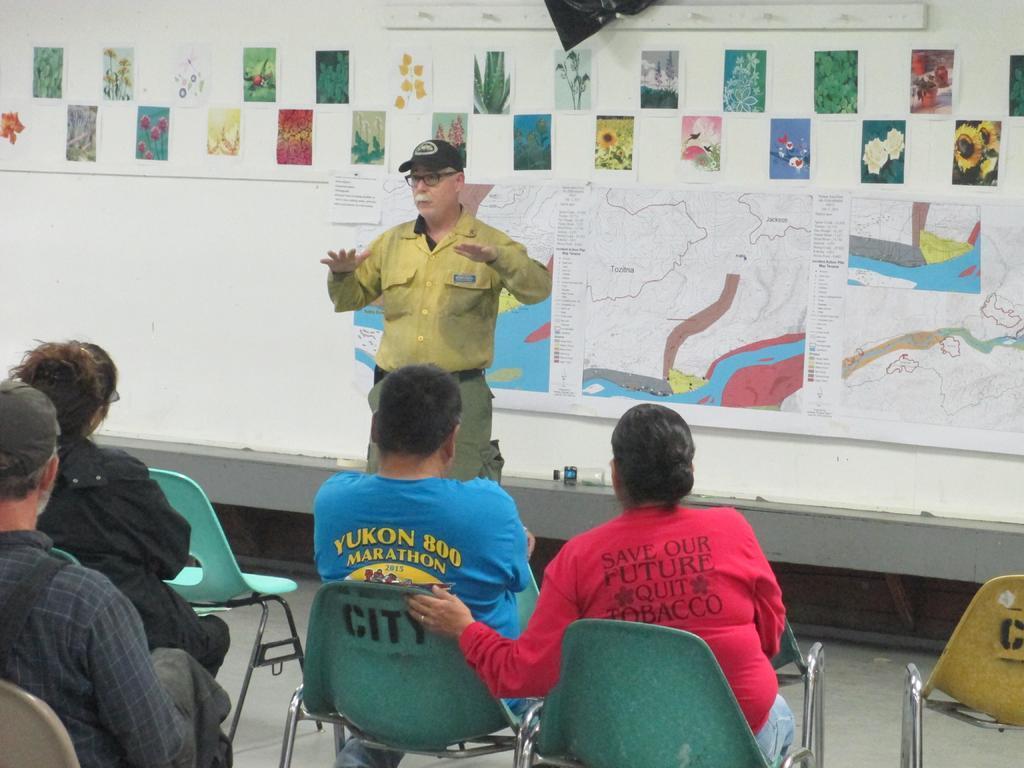Please provide a concise description of this image. A picture inside of a room. This persons are sitting on a chair. On wall there are different type of pictures and posters. This man is standing and wore yellow shirt and cap. 